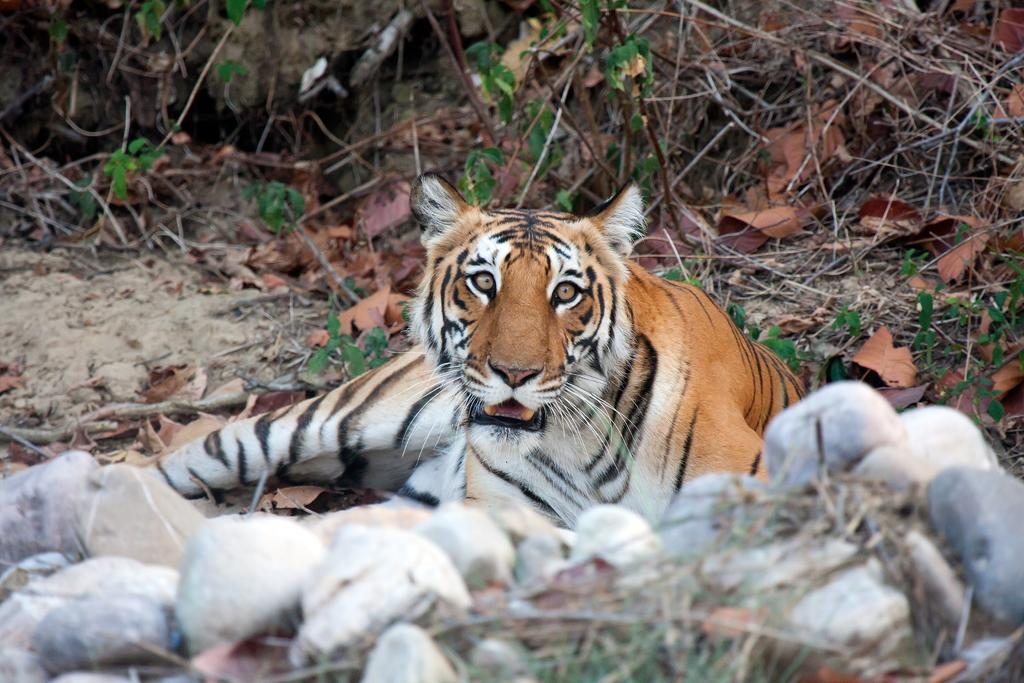What animal is sitting on the ground in the image? There is a tiger sitting on the ground in the image. What type of terrain is visible at the bottom of the image? Rocks and grass are present at the bottom of the image. What can be seen in the background of the image? Dried plants and leaves are visible in the background of the image. What activity is the girl participating in with the tiger in the image? There is no girl present in the image; it only features a tiger sitting on the ground. Is there a bomb visible in the image? No, there is no bomb present in the image. 